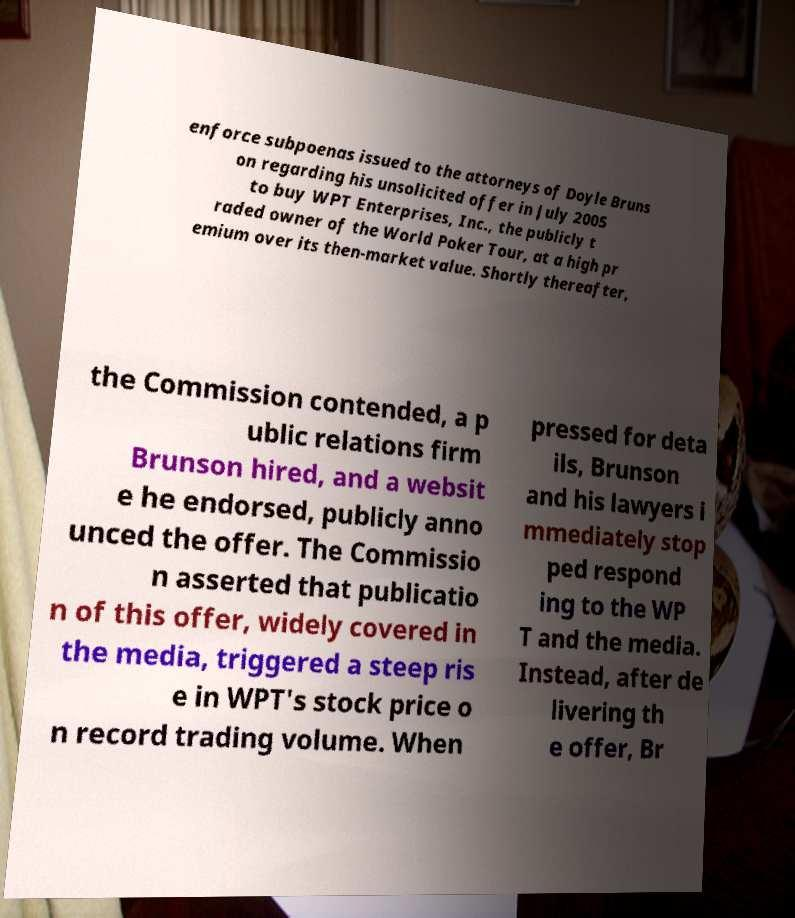For documentation purposes, I need the text within this image transcribed. Could you provide that? enforce subpoenas issued to the attorneys of Doyle Bruns on regarding his unsolicited offer in July 2005 to buy WPT Enterprises, Inc., the publicly t raded owner of the World Poker Tour, at a high pr emium over its then-market value. Shortly thereafter, the Commission contended, a p ublic relations firm Brunson hired, and a websit e he endorsed, publicly anno unced the offer. The Commissio n asserted that publicatio n of this offer, widely covered in the media, triggered a steep ris e in WPT's stock price o n record trading volume. When pressed for deta ils, Brunson and his lawyers i mmediately stop ped respond ing to the WP T and the media. Instead, after de livering th e offer, Br 